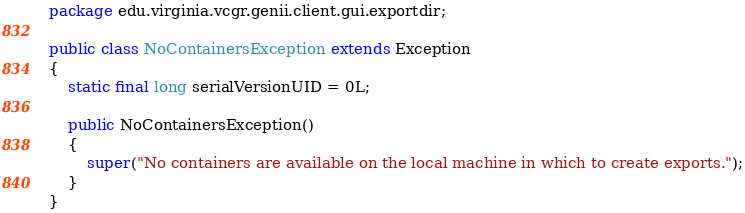Convert code to text. <code><loc_0><loc_0><loc_500><loc_500><_Java_>package edu.virginia.vcgr.genii.client.gui.exportdir;

public class NoContainersException extends Exception
{
	static final long serialVersionUID = 0L;

	public NoContainersException()
	{
		super("No containers are available on the local machine in which to create exports.");
	}
}</code> 